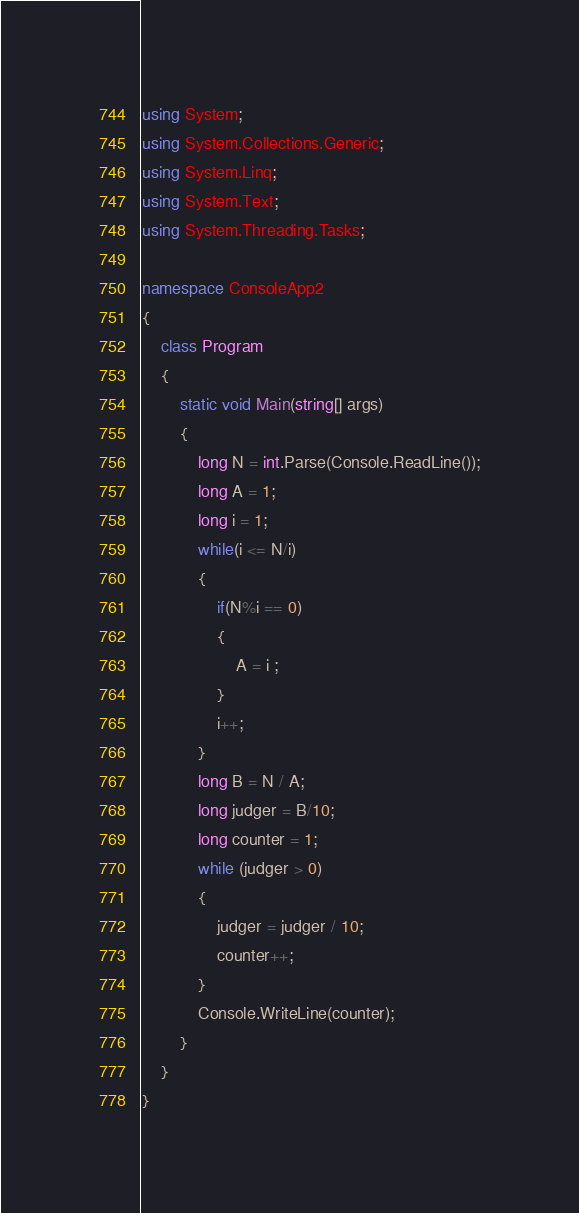<code> <loc_0><loc_0><loc_500><loc_500><_C#_>using System;
using System.Collections.Generic;
using System.Linq;
using System.Text;
using System.Threading.Tasks;

namespace ConsoleApp2
{
    class Program
    {
        static void Main(string[] args)
        {
            long N = int.Parse(Console.ReadLine());
            long A = 1;
            long i = 1;
            while(i <= N/i)
            {
                if(N%i == 0)
                {
                    A = i ;
                }
                i++;
            }
            long B = N / A;
            long judger = B/10;
            long counter = 1;
            while (judger > 0)
            {
                judger = judger / 10;
                counter++;
            }
            Console.WriteLine(counter);
        }
    }
}</code> 